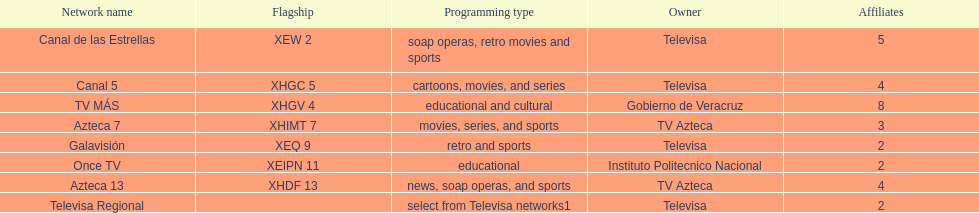In comparison to canal de las estrellas, how many networks are there with more affiliates? 1. 